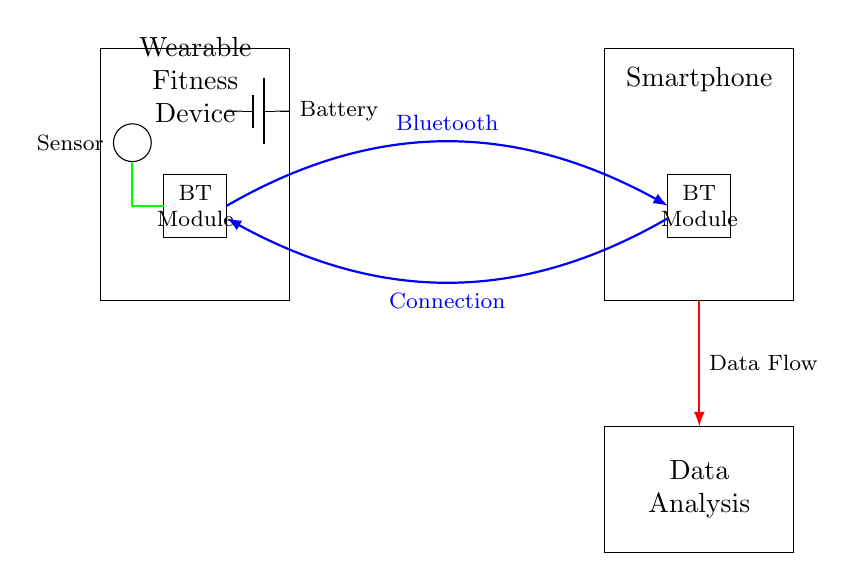What is the main function of the blue connection? The blue connection indicates a Bluetooth communication link between the wearable fitness device and the smartphone, which allows for data transfer wirelessly.
Answer: Bluetooth communication link What type of battery is used in this circuit? The circuit diagram indicates a generic battery symbol, which suggests a standard battery type is used. However, the specific type is not detailed in the diagram.
Answer: Generic battery How many devices are connected via Bluetooth? There are two devices shown in the circuit: the wearable fitness device and the smartphone, both linked via Bluetooth.
Answer: Two devices What is the role of the sensor in the wearable device? The sensor in the wearable device collects data such as physical activity metrics, heart rate, etc., which is then transmitted to the smartphone for analysis.
Answer: Data collection Describe the data flow direction in the circuit. The data flows from the Bluetooth module in the smartphone to the Data Analysis component, as indicated by the red arrow pointing downwards. This shows how data is processed after collection.
Answer: Downwards What happens to the data after it leaves the wearable device? After leaving the wearable device, the data is transmitted via the Bluetooth connection to the smartphone for data analysis, indicating that the smartphone is responsible for processing the transmitted data.
Answer: Data analysis What color represents the data connection in this circuit? The data connection is represented by a red line, which typically indicates a data flow or transfer within circuit diagrams.
Answer: Red 